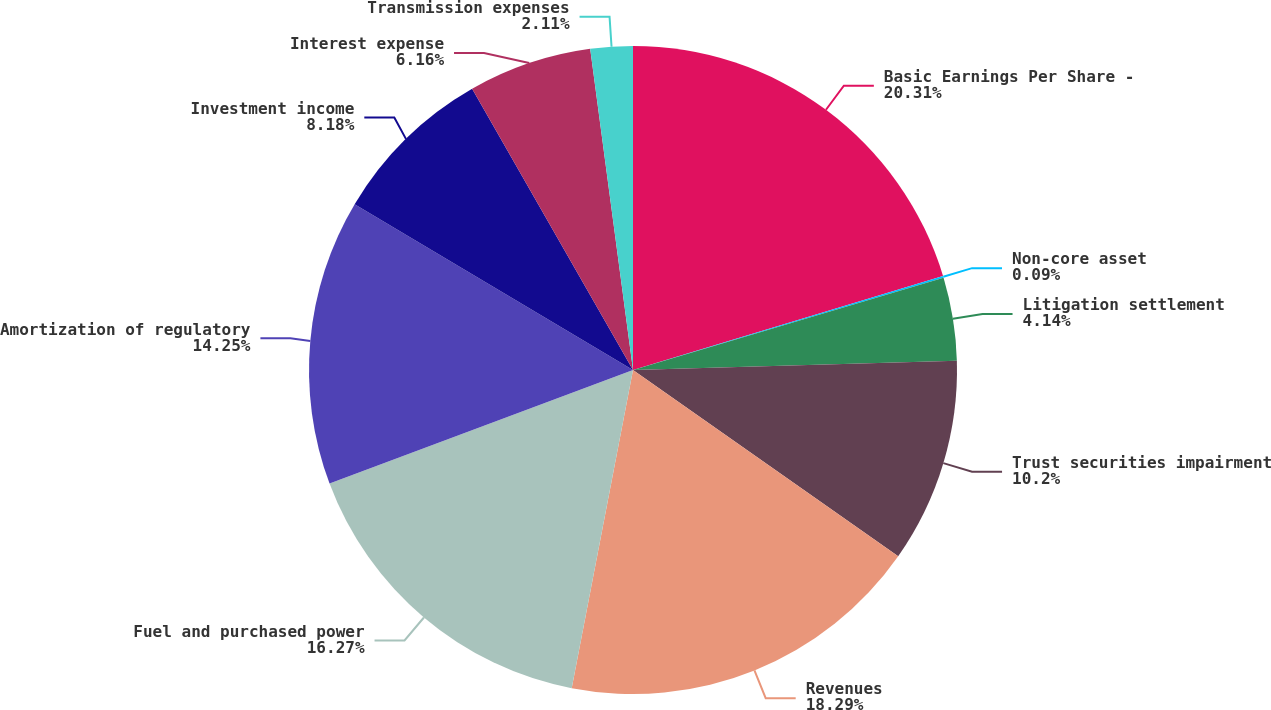Convert chart. <chart><loc_0><loc_0><loc_500><loc_500><pie_chart><fcel>Basic Earnings Per Share -<fcel>Non-core asset<fcel>Litigation settlement<fcel>Trust securities impairment<fcel>Revenues<fcel>Fuel and purchased power<fcel>Amortization of regulatory<fcel>Investment income<fcel>Interest expense<fcel>Transmission expenses<nl><fcel>20.31%<fcel>0.09%<fcel>4.14%<fcel>10.2%<fcel>18.29%<fcel>16.27%<fcel>14.25%<fcel>8.18%<fcel>6.16%<fcel>2.11%<nl></chart> 